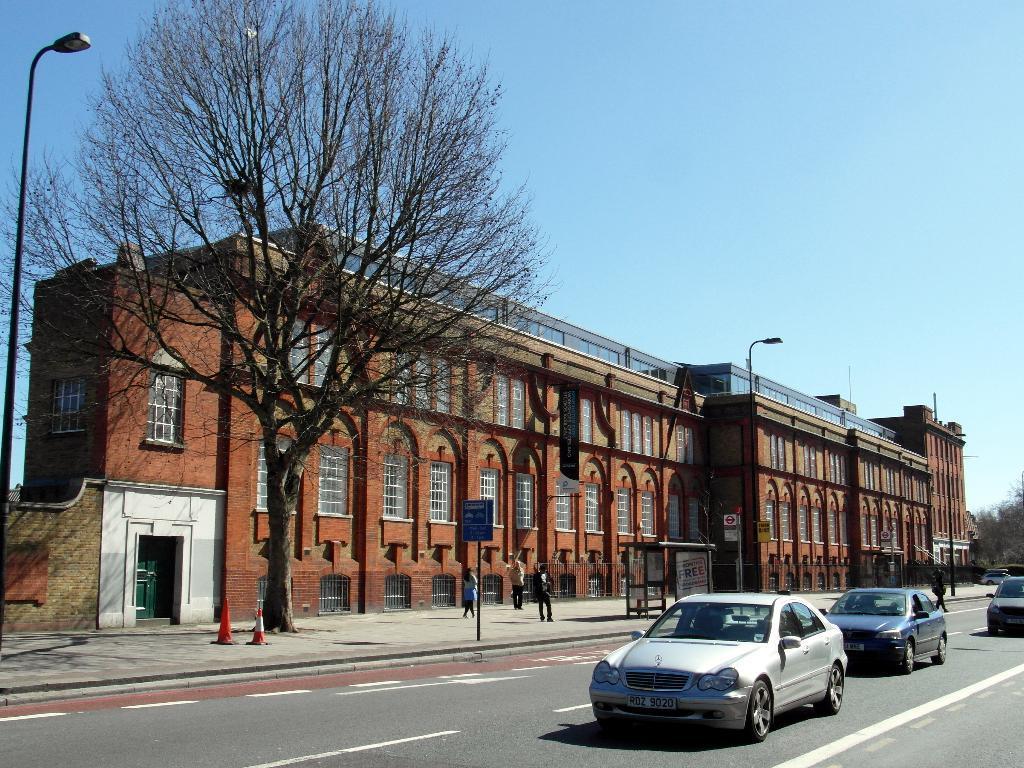Please provide a concise description of this image. In this image we can see one big building with red walls, some trees, one person walking on the road, one banner, two safety pole, three people are on the footpath, so many glass windows, one green door, two street lights, some boards, two poles attached to the building and at the top there is the sky. There are three cars on the road and one card parked in front of the building. 